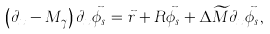Convert formula to latex. <formula><loc_0><loc_0><loc_500><loc_500>\left ( \partial _ { x } - M _ { \gamma } \right ) \partial _ { x } \vec { \phi } _ { s } = \vec { r } + R \vec { \phi } _ { s } + \Delta \widetilde { M } \partial _ { x } \vec { \phi } _ { s } ,</formula> 